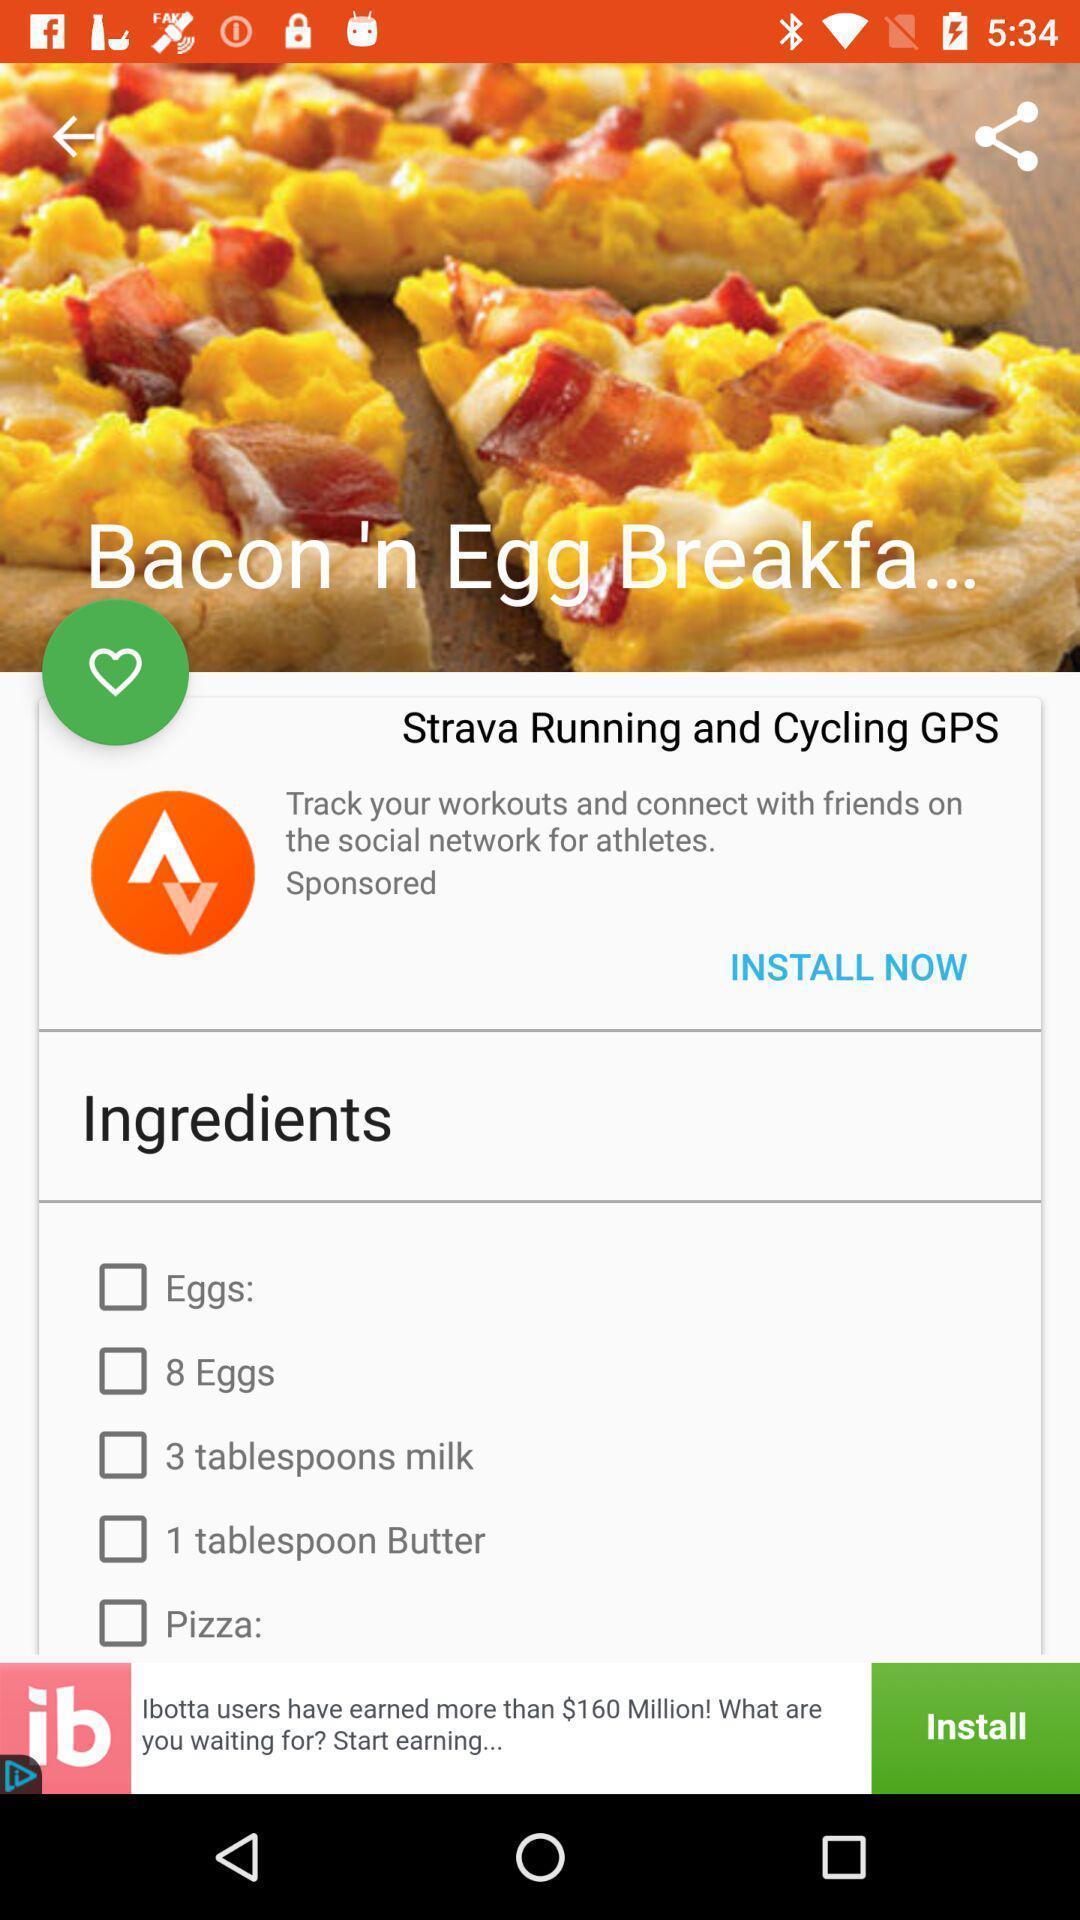What can you discern from this picture? Screen displaying recipe. 